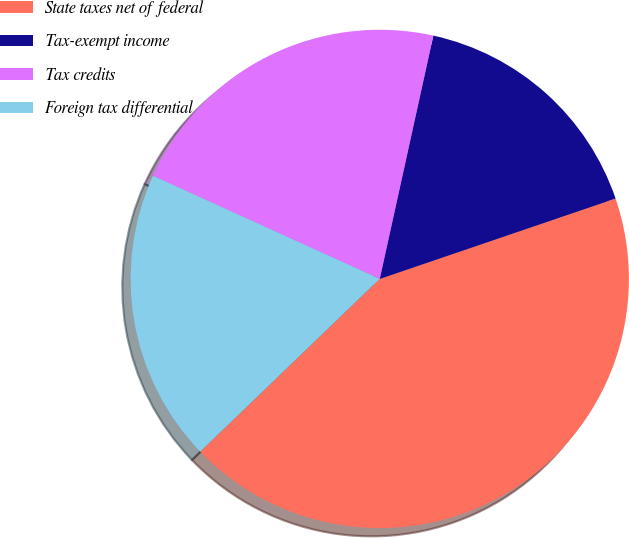Convert chart. <chart><loc_0><loc_0><loc_500><loc_500><pie_chart><fcel>State taxes net of federal<fcel>Tax-exempt income<fcel>Tax credits<fcel>Foreign tax differential<nl><fcel>43.03%<fcel>16.32%<fcel>21.66%<fcel>18.99%<nl></chart> 